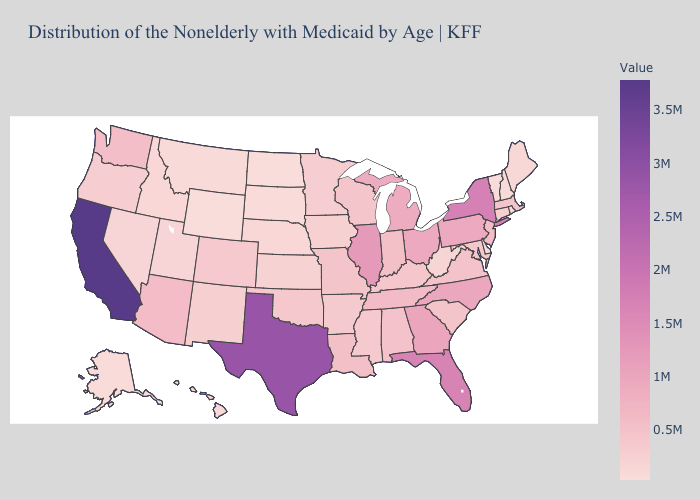Which states have the lowest value in the USA?
Write a very short answer. North Dakota. Which states have the lowest value in the South?
Keep it brief. Delaware. Does California have the highest value in the USA?
Write a very short answer. Yes. Among the states that border Mississippi , does Arkansas have the lowest value?
Short answer required. Yes. Which states have the lowest value in the South?
Be succinct. Delaware. Which states have the highest value in the USA?
Give a very brief answer. California. 